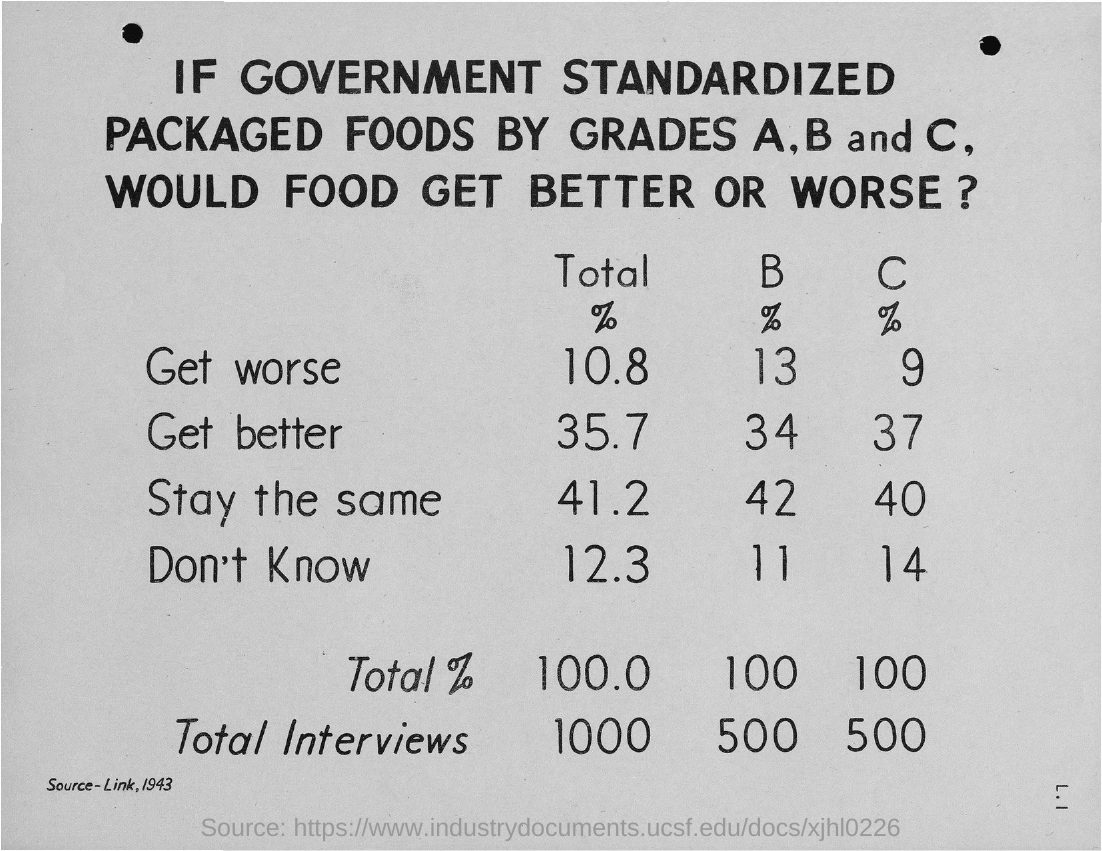Highlight a few significant elements in this photo. The document in question is titled "The Impact of Government Standardized Packaged Foods by Grades A, B and C on the Quality of Food." It explores the possibility of improved or worsened quality if the government were to implement a standardized system of packaged food grading. In terms of the percentage of responses indicating "Stay the same" for C, 40% is the most common. Out of all respondents, 11% chose the option "Don't Know" for question B. The percentage of "Get better" for B is 34%. 